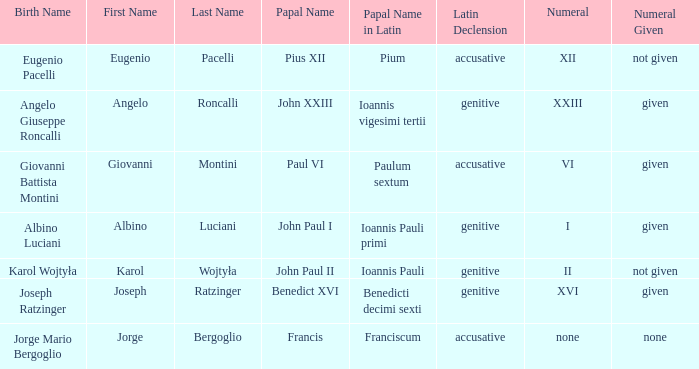What numeral is included for the pope with papal name in Latin of Ioannis Pauli? Not given. 